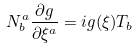Convert formula to latex. <formula><loc_0><loc_0><loc_500><loc_500>N ^ { a } _ { b } \frac { { \partial } g } { { \partial } { \xi } ^ { a } } = i g ( { \xi } ) T _ { b }</formula> 